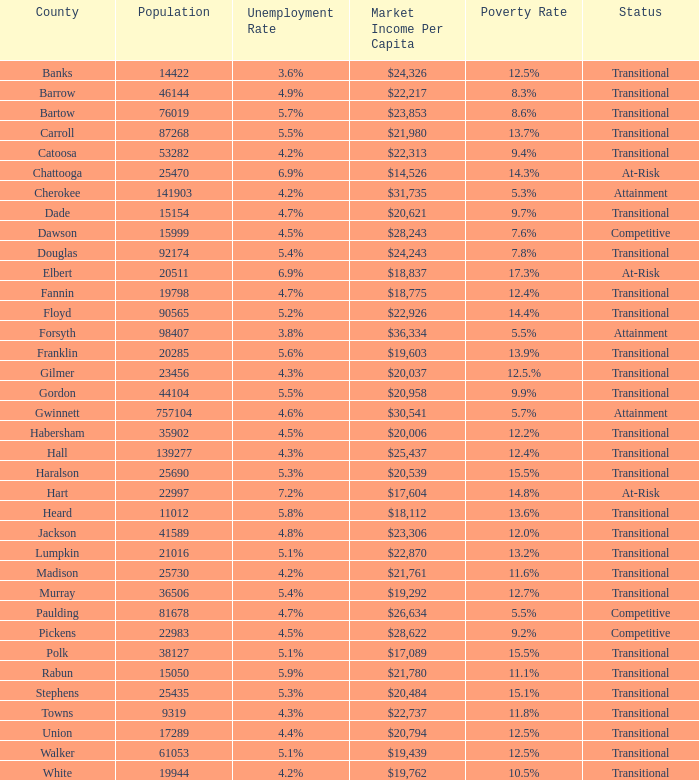What is the market income per capita of the county with the 9.4% poverty rate? $22,313. Can you parse all the data within this table? {'header': ['County', 'Population', 'Unemployment Rate', 'Market Income Per Capita', 'Poverty Rate', 'Status'], 'rows': [['Banks', '14422', '3.6%', '$24,326', '12.5%', 'Transitional'], ['Barrow', '46144', '4.9%', '$22,217', '8.3%', 'Transitional'], ['Bartow', '76019', '5.7%', '$23,853', '8.6%', 'Transitional'], ['Carroll', '87268', '5.5%', '$21,980', '13.7%', 'Transitional'], ['Catoosa', '53282', '4.2%', '$22,313', '9.4%', 'Transitional'], ['Chattooga', '25470', '6.9%', '$14,526', '14.3%', 'At-Risk'], ['Cherokee', '141903', '4.2%', '$31,735', '5.3%', 'Attainment'], ['Dade', '15154', '4.7%', '$20,621', '9.7%', 'Transitional'], ['Dawson', '15999', '4.5%', '$28,243', '7.6%', 'Competitive'], ['Douglas', '92174', '5.4%', '$24,243', '7.8%', 'Transitional'], ['Elbert', '20511', '6.9%', '$18,837', '17.3%', 'At-Risk'], ['Fannin', '19798', '4.7%', '$18,775', '12.4%', 'Transitional'], ['Floyd', '90565', '5.2%', '$22,926', '14.4%', 'Transitional'], ['Forsyth', '98407', '3.8%', '$36,334', '5.5%', 'Attainment'], ['Franklin', '20285', '5.6%', '$19,603', '13.9%', 'Transitional'], ['Gilmer', '23456', '4.3%', '$20,037', '12.5.%', 'Transitional'], ['Gordon', '44104', '5.5%', '$20,958', '9.9%', 'Transitional'], ['Gwinnett', '757104', '4.6%', '$30,541', '5.7%', 'Attainment'], ['Habersham', '35902', '4.5%', '$20,006', '12.2%', 'Transitional'], ['Hall', '139277', '4.3%', '$25,437', '12.4%', 'Transitional'], ['Haralson', '25690', '5.3%', '$20,539', '15.5%', 'Transitional'], ['Hart', '22997', '7.2%', '$17,604', '14.8%', 'At-Risk'], ['Heard', '11012', '5.8%', '$18,112', '13.6%', 'Transitional'], ['Jackson', '41589', '4.8%', '$23,306', '12.0%', 'Transitional'], ['Lumpkin', '21016', '5.1%', '$22,870', '13.2%', 'Transitional'], ['Madison', '25730', '4.2%', '$21,761', '11.6%', 'Transitional'], ['Murray', '36506', '5.4%', '$19,292', '12.7%', 'Transitional'], ['Paulding', '81678', '4.7%', '$26,634', '5.5%', 'Competitive'], ['Pickens', '22983', '4.5%', '$28,622', '9.2%', 'Competitive'], ['Polk', '38127', '5.1%', '$17,089', '15.5%', 'Transitional'], ['Rabun', '15050', '5.9%', '$21,780', '11.1%', 'Transitional'], ['Stephens', '25435', '5.3%', '$20,484', '15.1%', 'Transitional'], ['Towns', '9319', '4.3%', '$22,737', '11.8%', 'Transitional'], ['Union', '17289', '4.4%', '$20,794', '12.5%', 'Transitional'], ['Walker', '61053', '5.1%', '$19,439', '12.5%', 'Transitional'], ['White', '19944', '4.2%', '$19,762', '10.5%', 'Transitional']]} 